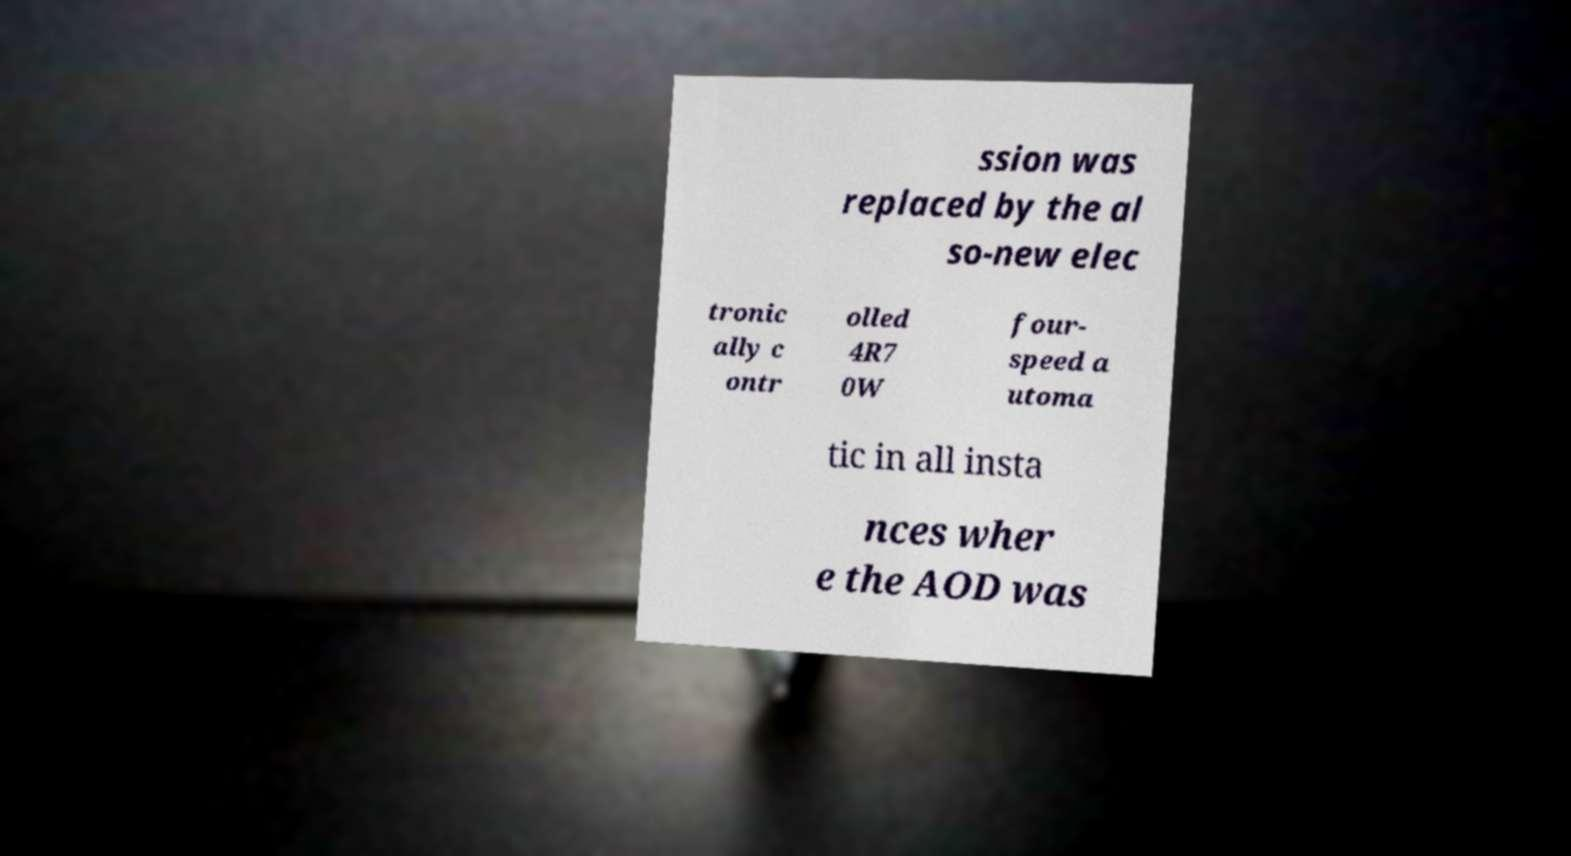What messages or text are displayed in this image? I need them in a readable, typed format. ssion was replaced by the al so-new elec tronic ally c ontr olled 4R7 0W four- speed a utoma tic in all insta nces wher e the AOD was 